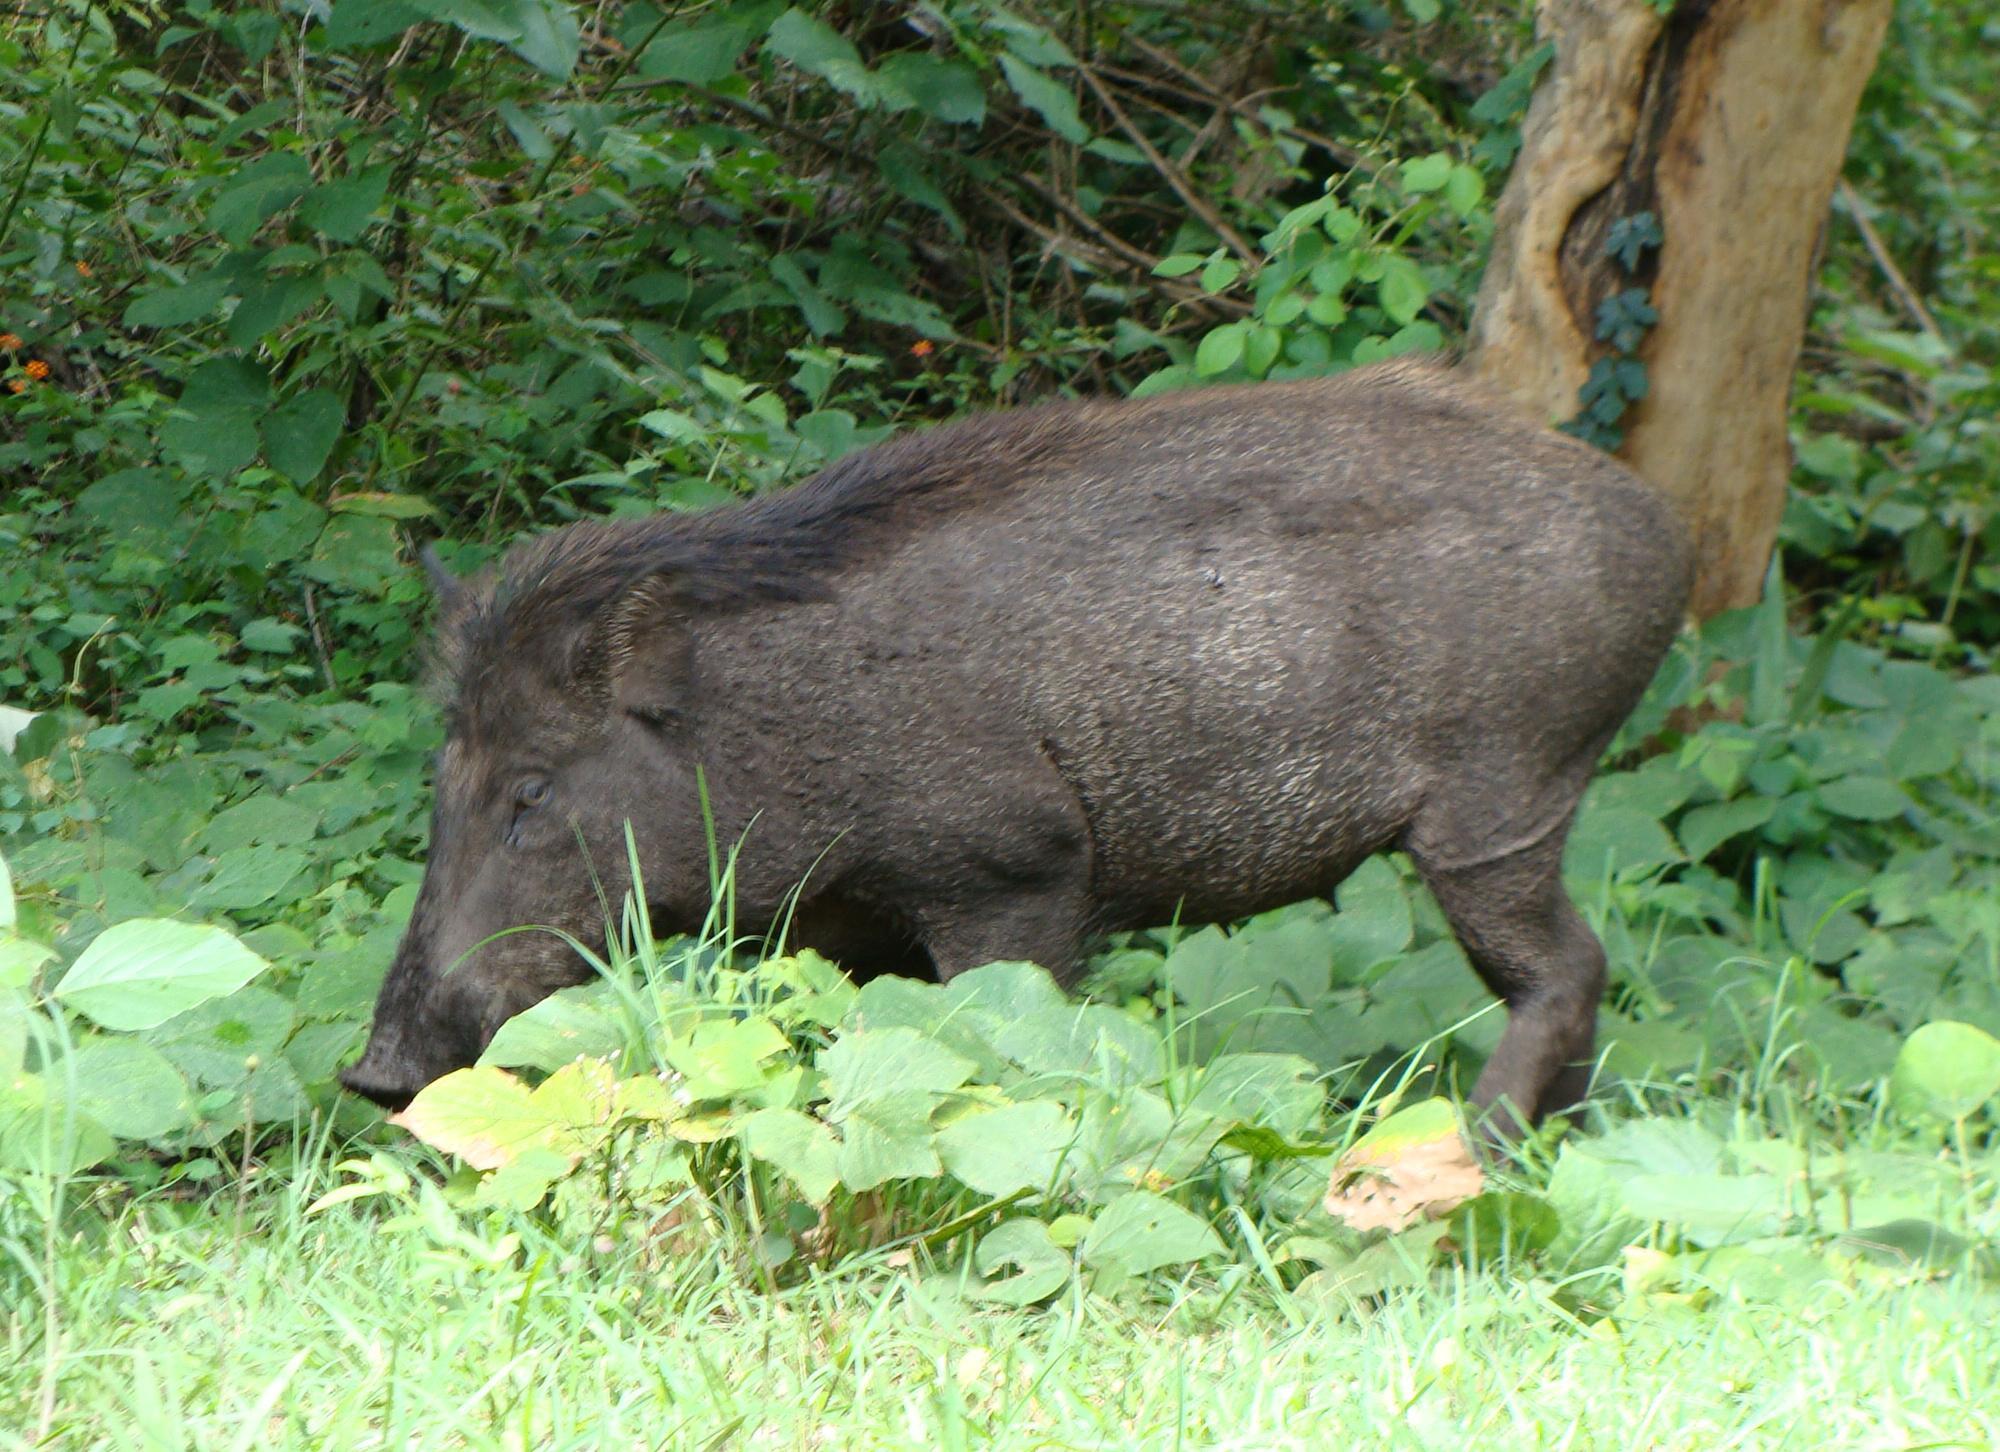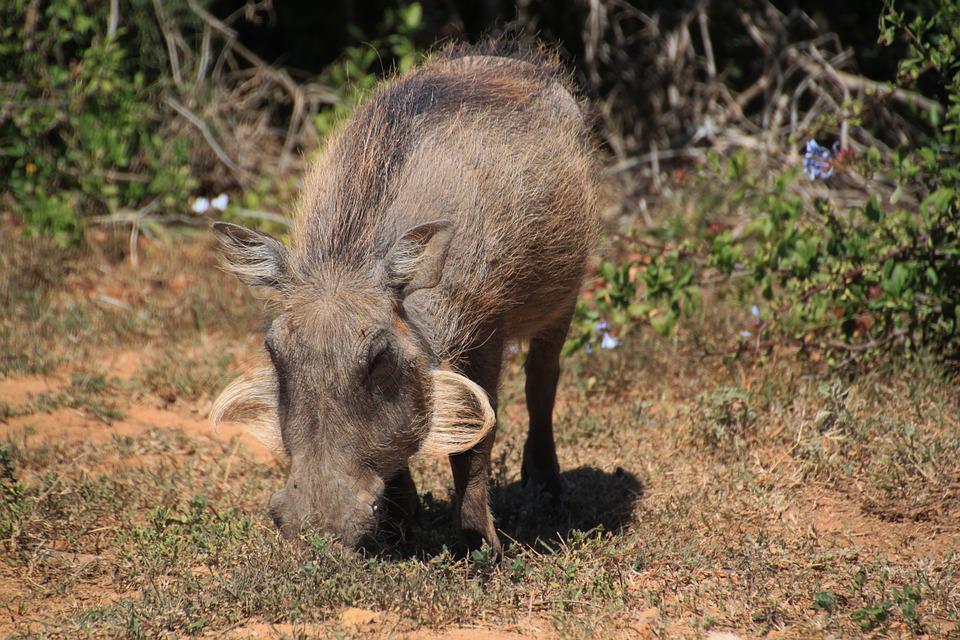The first image is the image on the left, the second image is the image on the right. Analyze the images presented: Is the assertion "A total of two animals are shown in a natural setting." valid? Answer yes or no. Yes. 